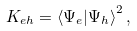<formula> <loc_0><loc_0><loc_500><loc_500>K _ { e h } = \left \langle \Psi _ { e } | \Psi _ { h } \right \rangle ^ { 2 } ,</formula> 